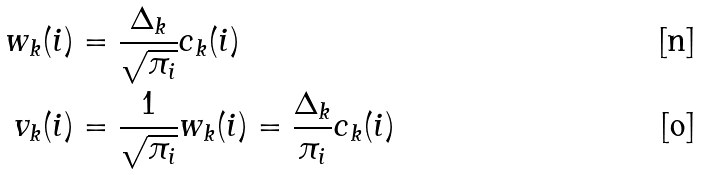<formula> <loc_0><loc_0><loc_500><loc_500>w _ { k } ( i ) & = \frac { \Delta _ { k } } { \sqrt { \pi _ { i } } } c _ { k } ( i ) \\ v _ { k } ( i ) & = \frac { 1 } { \sqrt { \pi _ { i } } } w _ { k } ( i ) = \frac { \Delta _ { k } } { \pi _ { i } } c _ { k } ( i )</formula> 